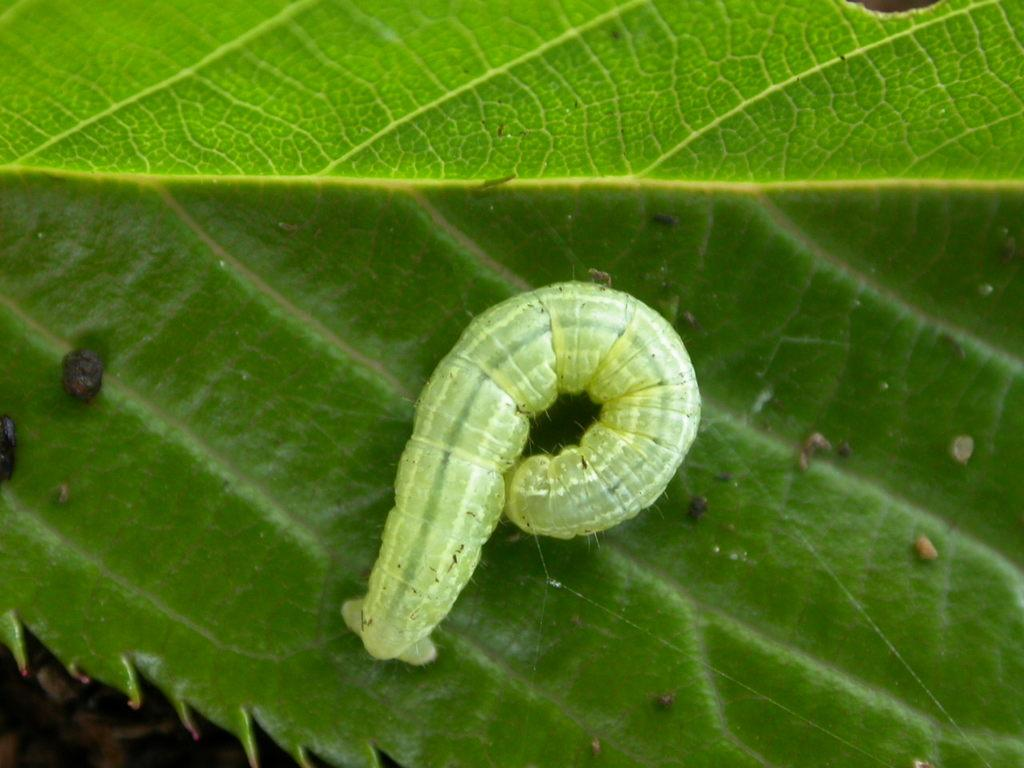What is the main subject of the image? The main subject of the image is a worm. Where is the worm located in the image? The worm is on a leaf in the image. What type of hospital is visible in the image? There is no hospital present in the image; it features a worm on a leaf. What ingredients are used to make the stew in the image? There is no stew present in the image; it features a worm on a leaf. 